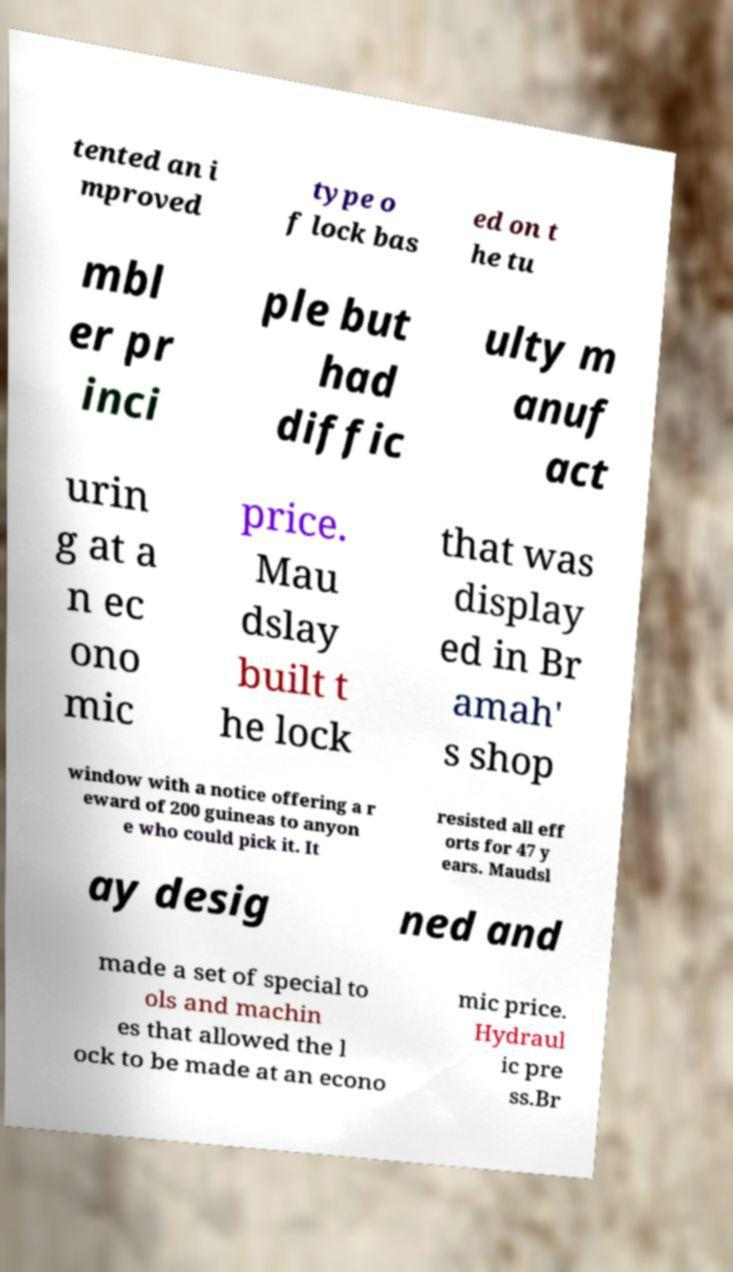I need the written content from this picture converted into text. Can you do that? tented an i mproved type o f lock bas ed on t he tu mbl er pr inci ple but had diffic ulty m anuf act urin g at a n ec ono mic price. Mau dslay built t he lock that was display ed in Br amah' s shop window with a notice offering a r eward of 200 guineas to anyon e who could pick it. It resisted all eff orts for 47 y ears. Maudsl ay desig ned and made a set of special to ols and machin es that allowed the l ock to be made at an econo mic price. Hydraul ic pre ss.Br 